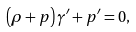<formula> <loc_0><loc_0><loc_500><loc_500>\left ( \rho + p \right ) \gamma ^ { \prime } + p ^ { \prime } = 0 ,</formula> 